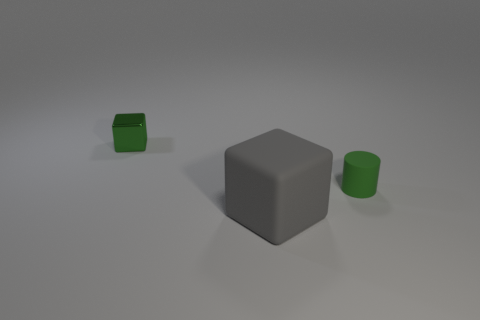There is a tiny thing in front of the tiny block; is its color the same as the thing that is on the left side of the gray thing?
Give a very brief answer. Yes. Does the green thing that is left of the gray cube have the same material as the tiny green cylinder?
Provide a succinct answer. No. Are there any red cylinders?
Your answer should be very brief. No. There is a thing that is on the right side of the small metal block and to the left of the small green matte thing; how big is it?
Keep it short and to the point. Large. Are there more tiny matte things behind the gray matte cube than small metal objects that are in front of the green cylinder?
Keep it short and to the point. Yes. What color is the small cube?
Your answer should be compact. Green. The object that is to the left of the small green cylinder and right of the metallic cube is what color?
Offer a very short reply. Gray. What is the color of the tiny shiny thing behind the cube that is in front of the block that is behind the green matte thing?
Your response must be concise. Green. What is the color of the block that is the same size as the green matte cylinder?
Ensure brevity in your answer.  Green. What shape is the small green object right of the small object that is behind the matte object that is on the right side of the large matte object?
Your answer should be compact. Cylinder. 